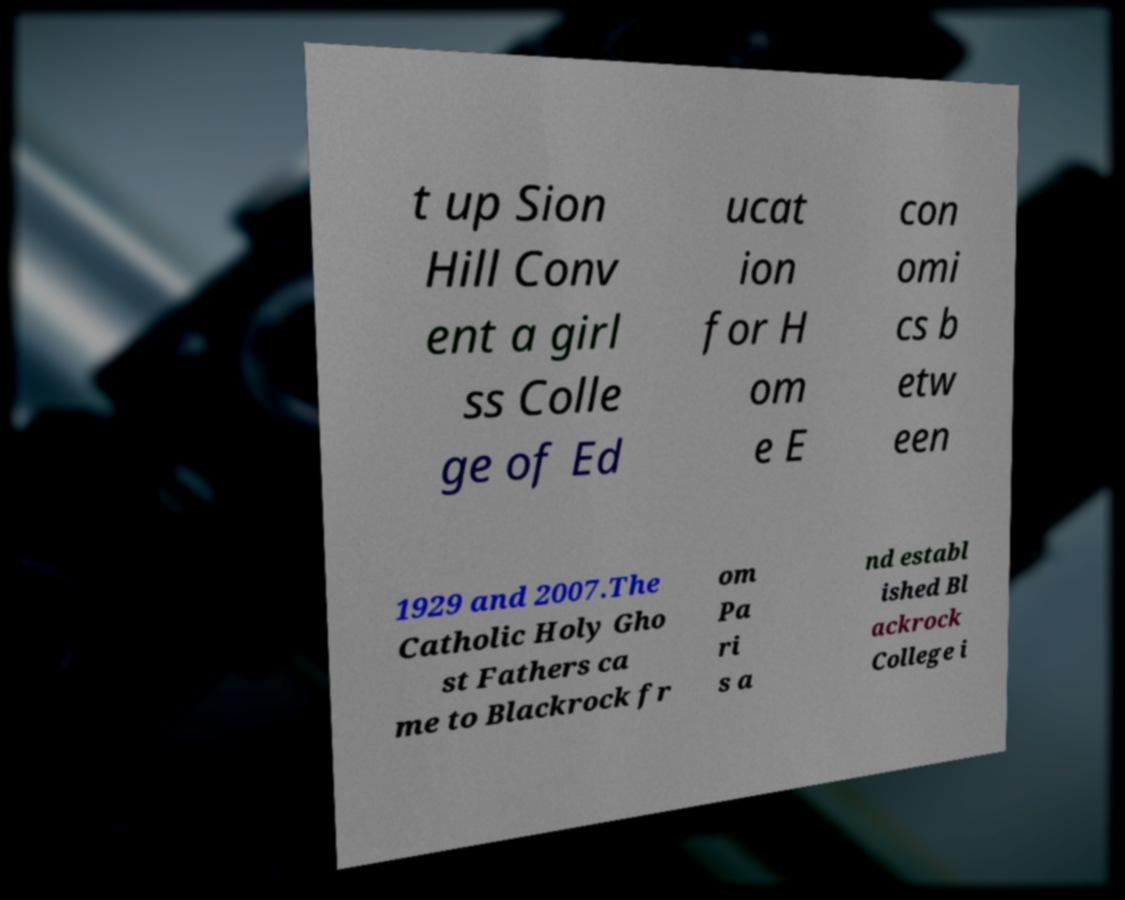There's text embedded in this image that I need extracted. Can you transcribe it verbatim? t up Sion Hill Conv ent a girl ss Colle ge of Ed ucat ion for H om e E con omi cs b etw een 1929 and 2007.The Catholic Holy Gho st Fathers ca me to Blackrock fr om Pa ri s a nd establ ished Bl ackrock College i 